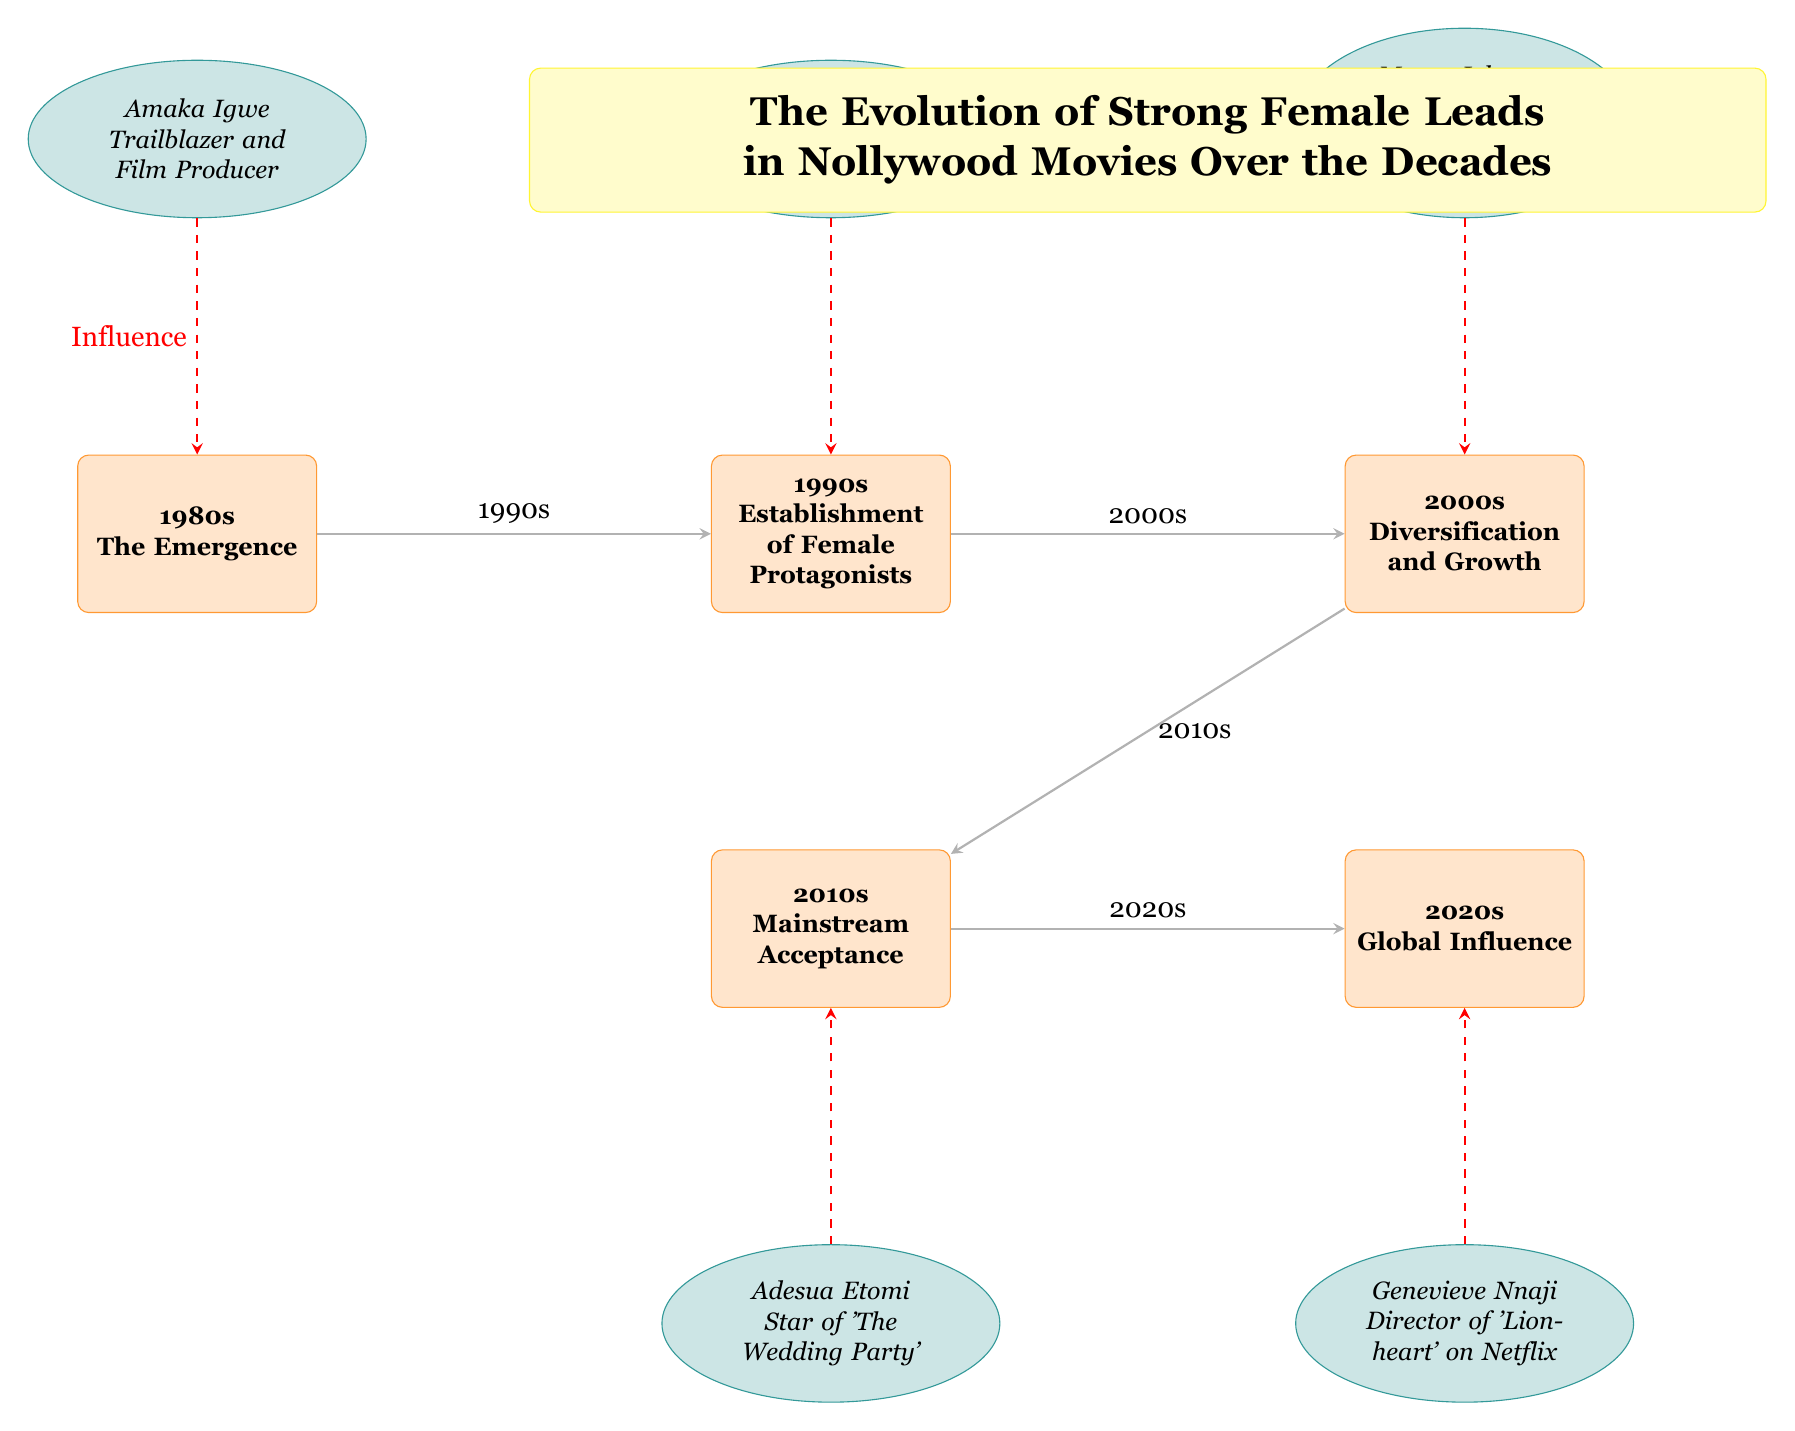What decade is represented as the "Emergence" of strong female leads? The diagram shows the 1980s as the decade labeled with "The Emergence," confirming the identification of this specific timeframe related to strong female leads in Nollywood.
Answer: 1980s Which actress is a trailblazer and film producer in the 1980s? Looking at the diagram, Amaka Igwe is specifically noted as the trailblazer and film producer associated with the 1980s, making her the key figure of that decade.
Answer: Amaka Igwe What significant development occurred in the 1990s? The diagram indicates the 1990s as the decade for the "Establishment of Female Protagonists," showing a key advancement in featuring strong female leads in Nollywood films.
Answer: Establishment of Female Protagonists How many actresses are represented in the diagram? Counting the number of actresses in the diagram, we find there are five distinct actresses recognized, which illustrates the variety of strong female lead characters over the decades in Nollywood.
Answer: 5 In which decade did Genevieve Nnaji appear as an iconic actress? According to the diagram, Genevieve Nnaji is depicted as an iconic actress in the 1990s, highlighted by her notable role in the film 'Ijé'.
Answer: 1990s What impact did Mercy Johnson have in the 2000s? The diagram highlights Mercy Johnson's role as a versatile performer in the 2000s, indicating her contribution to strong female representation during this period in Nollywood.
Answer: Versatile Performer in 'Dumebi the Dirty Girl' Which decade saw mainstream acceptance of strong female leads? The diagram notes that the 2010s represent the decade of "Mainstream Acceptance," signifying a critical shift towards recognizing strong female characters in Nollywood films during this time.
Answer: 2010s Which actress directed the film 'Lionheart'? The diagram specifies that Genevieve Nnaji directed 'Lionheart' in the 2020s, demonstrating her influential role not just as an actress but also as a director.
Answer: Genevieve Nnaji What is the nature of the connections between decades in the diagram? The flows between the decades are represented by solid arrows, indicating a progression or evolution of strong female leads from one decade to the next, demonstrating continuity and development in their representation.
Answer: Solid arrows indicate evolution How does the influence of characters in the diagram operate? The influence of various actresses over their respective decades is depicted by dashed red arrows leading from the actresses to their corresponding decades, emphasizing their impact on the evolution of strong female leads in Nollywood films.
Answer: Dashed red arrows 